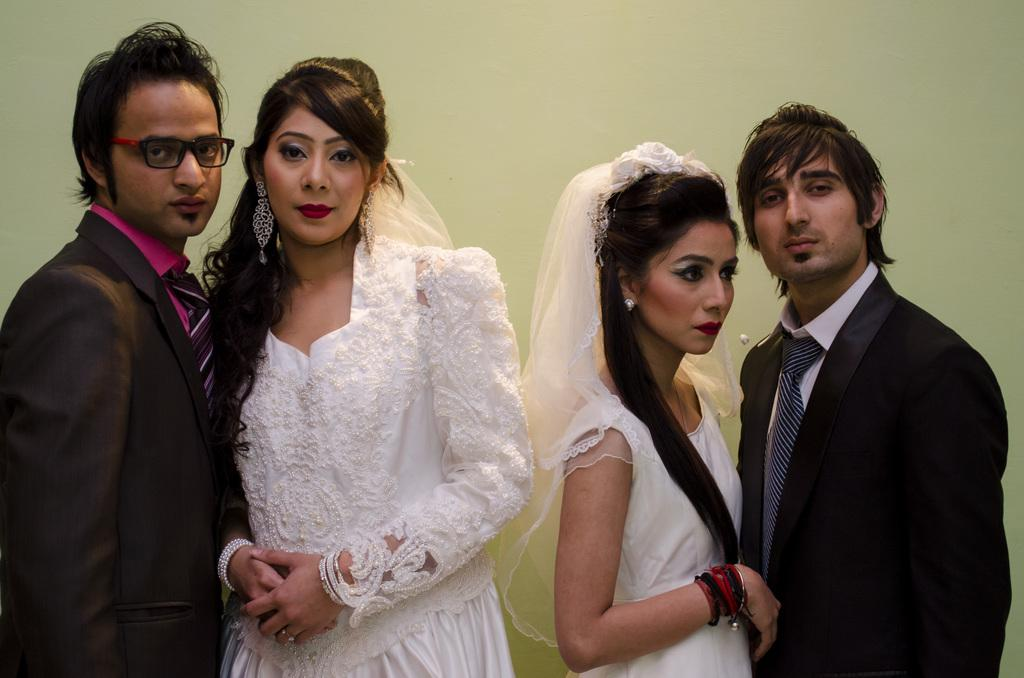How many couples are present in the image? There are two couples in the image, one on the right side and another on the left side. What is the background of the image? There is a wall in the background of the image. What is the color of the wall? The wall is painted green. Is there any sleet falling in the image? There is no mention of sleet or any weather conditions in the image. What is the couple's desire in the image? The image does not provide any information about the couple's desires or emotions. 